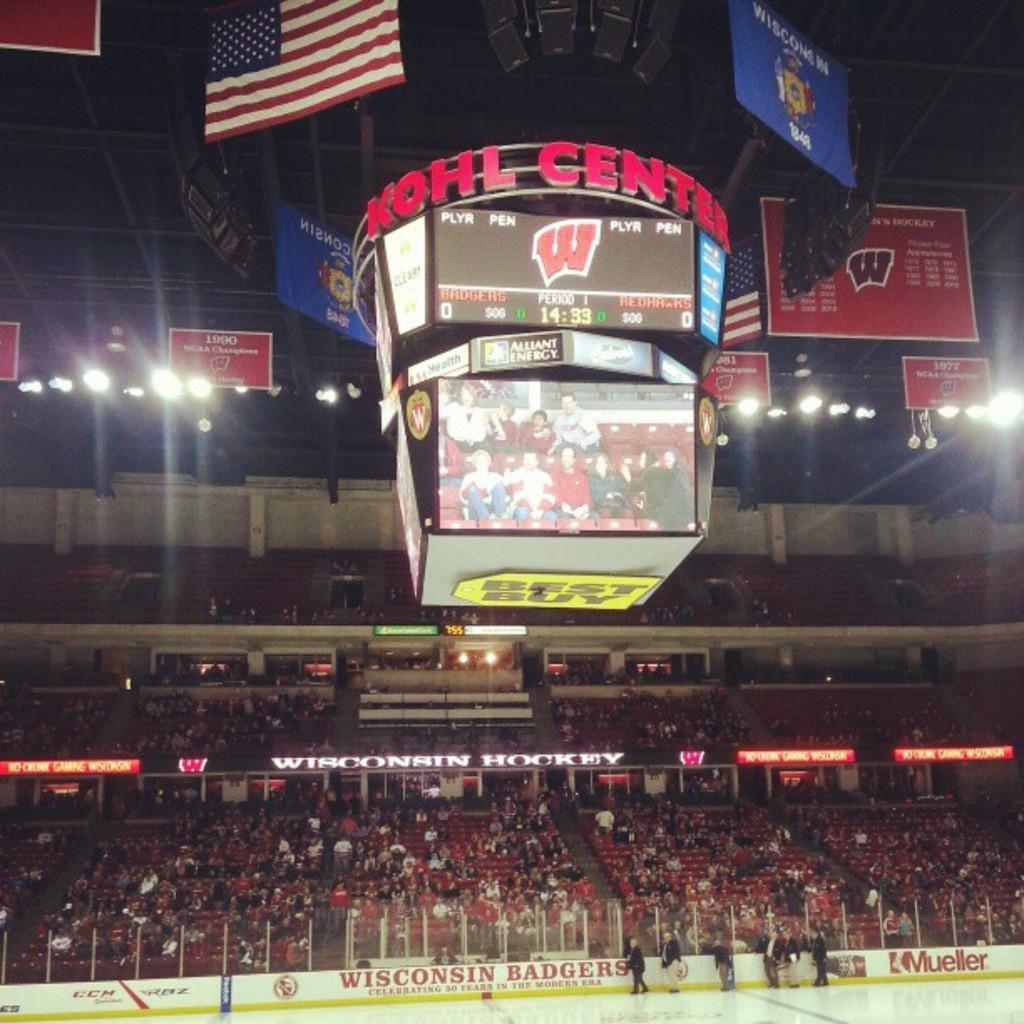<image>
Give a short and clear explanation of the subsequent image. The enormous scoreboard at the Kohl Center hangs over a virtually deserted ice hockey rink. 